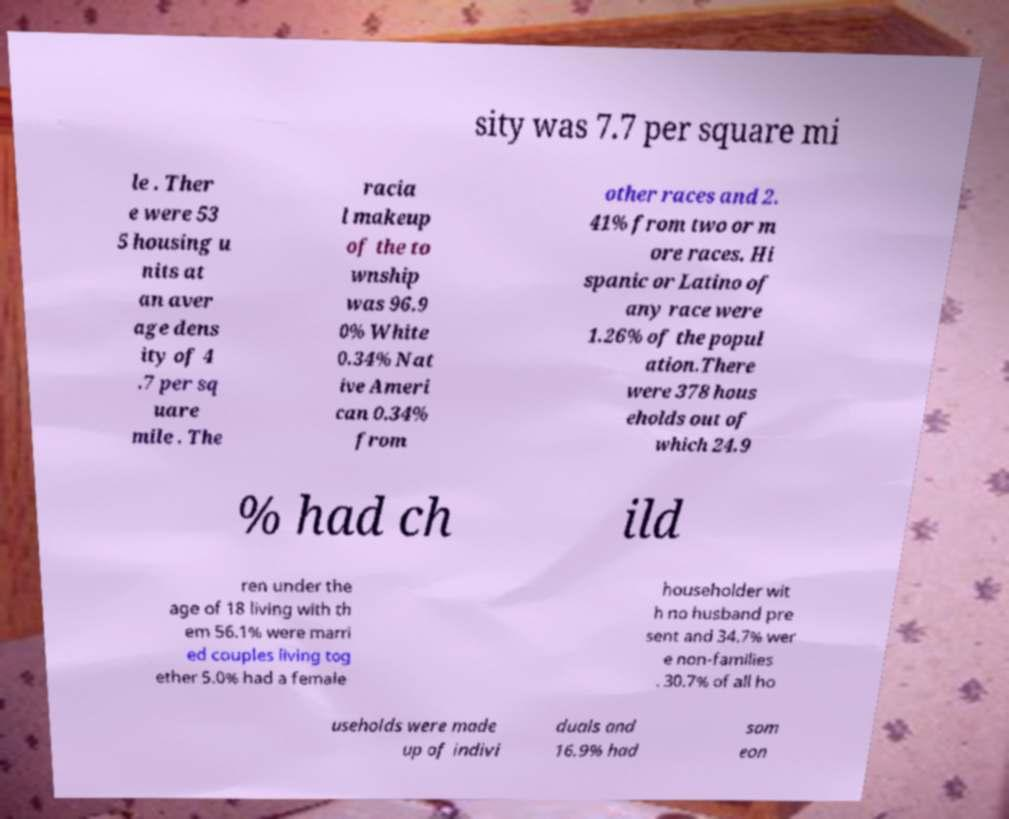Can you read and provide the text displayed in the image?This photo seems to have some interesting text. Can you extract and type it out for me? sity was 7.7 per square mi le . Ther e were 53 5 housing u nits at an aver age dens ity of 4 .7 per sq uare mile . The racia l makeup of the to wnship was 96.9 0% White 0.34% Nat ive Ameri can 0.34% from other races and 2. 41% from two or m ore races. Hi spanic or Latino of any race were 1.26% of the popul ation.There were 378 hous eholds out of which 24.9 % had ch ild ren under the age of 18 living with th em 56.1% were marri ed couples living tog ether 5.0% had a female householder wit h no husband pre sent and 34.7% wer e non-families . 30.7% of all ho useholds were made up of indivi duals and 16.9% had som eon 